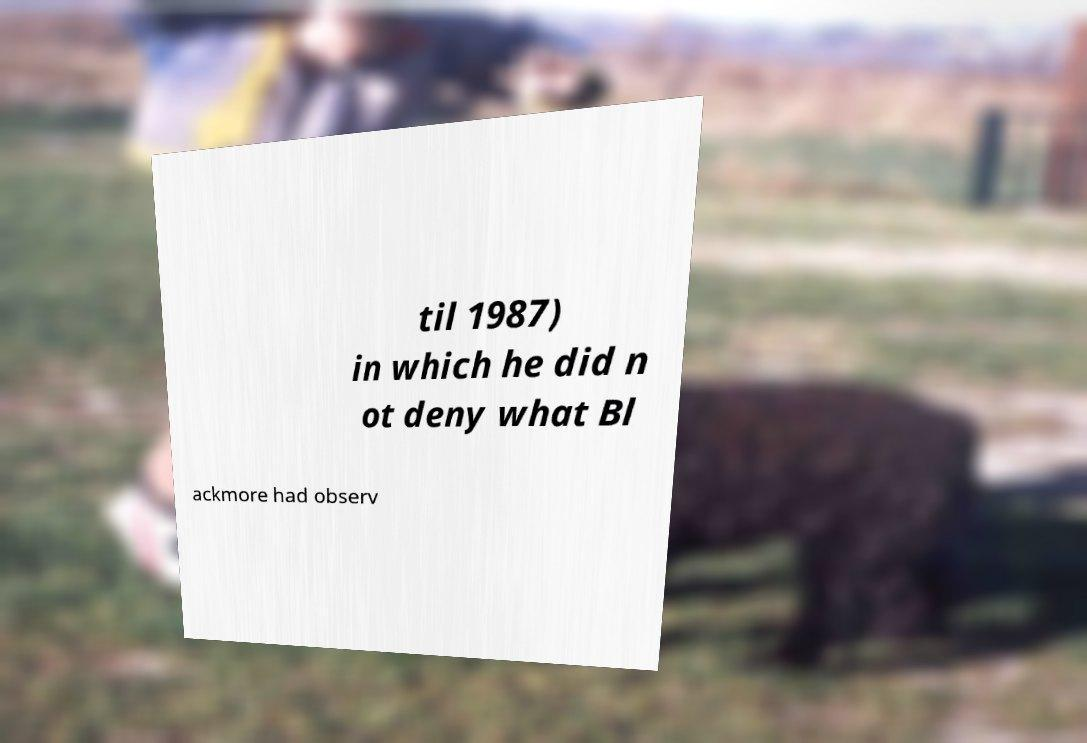Can you accurately transcribe the text from the provided image for me? til 1987) in which he did n ot deny what Bl ackmore had observ 